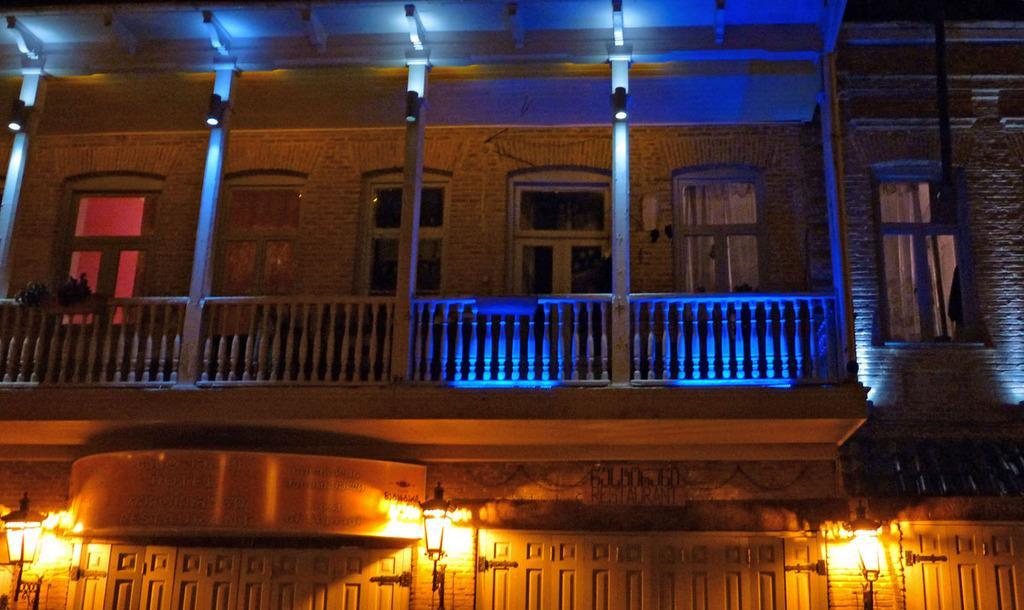How would you summarize this image in a sentence or two? In this image we can see a building, railing, board, lights, windows, and poles. 